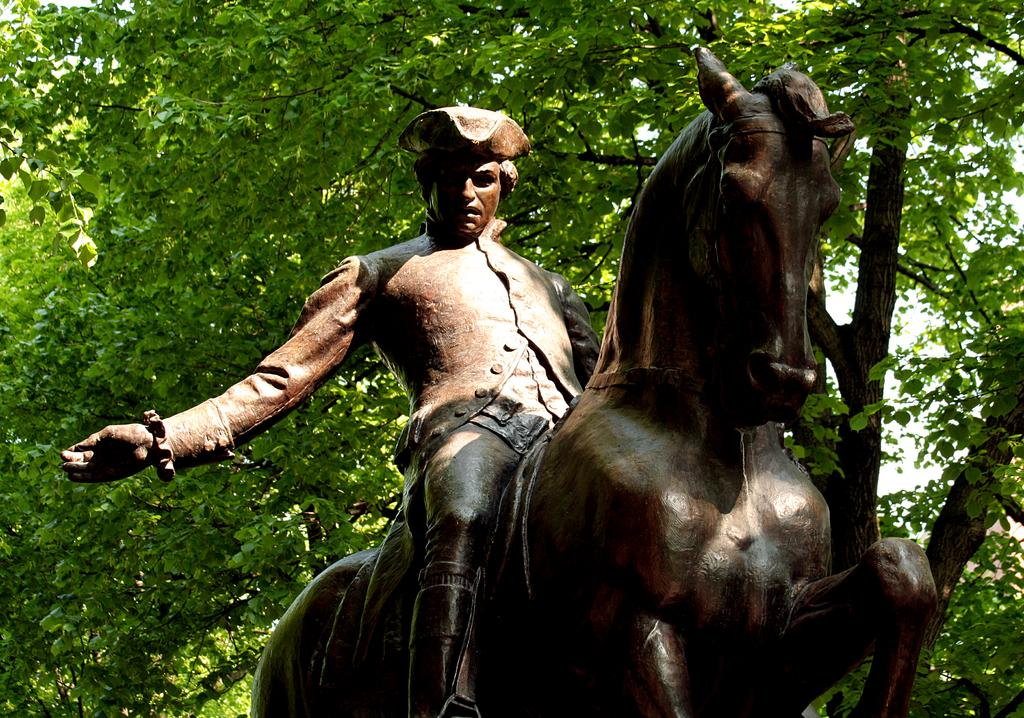What is the main subject of the image? The main subject of the image is a man sitting on a horse. What type of artwork is depicted in the image? The image appears to be a sculpture. What is the color of the sculpture? The sculpture is brown in color. What can be seen in the background of the image? There are trees with branches visible in the background of the image. What type of disease is affecting the horse in the image? There is no indication of any disease affecting the horse in the image, as it is a sculpture and not a living creature. 